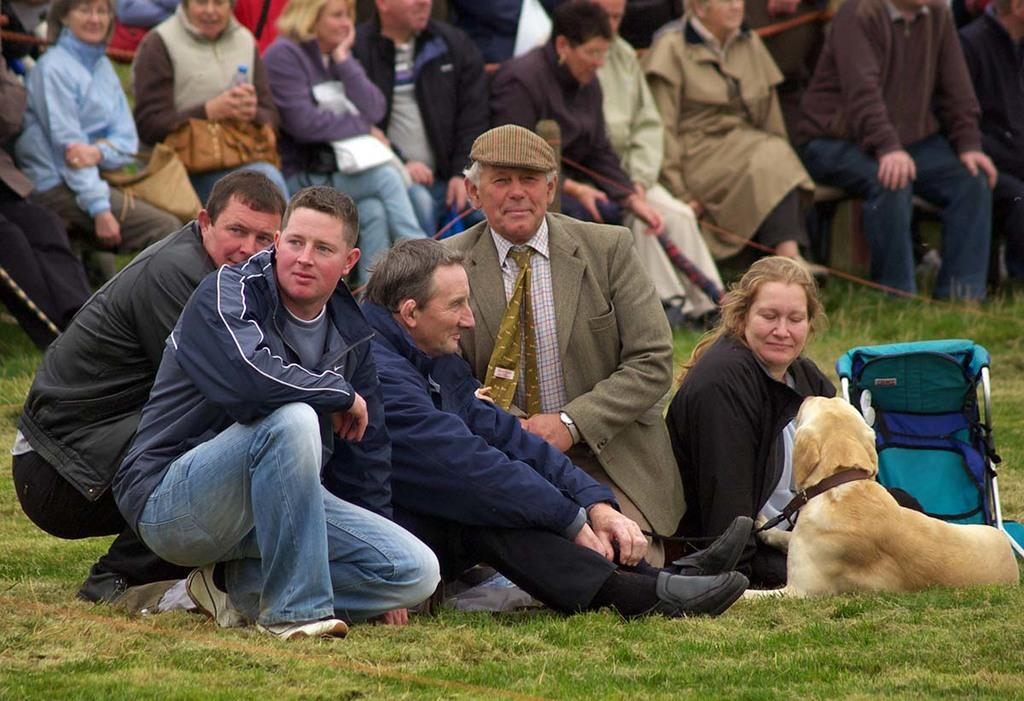What is the main subject in the image? There are people sitting in front of a dog in the image. What is the ground covered with? The ground is covered in greenery. Are there any other people visible in the image? Yes, there are people sitting on a bench behind the group in front of the dog. Can you tell me how many records are being played in the image? There are no records present in the image; it features people sitting in front of a dog and greenery on the ground. What type of harmony is being created by the cave in the image? There is no cave present in the image, so it is not possible to discuss any harmony created by it. 